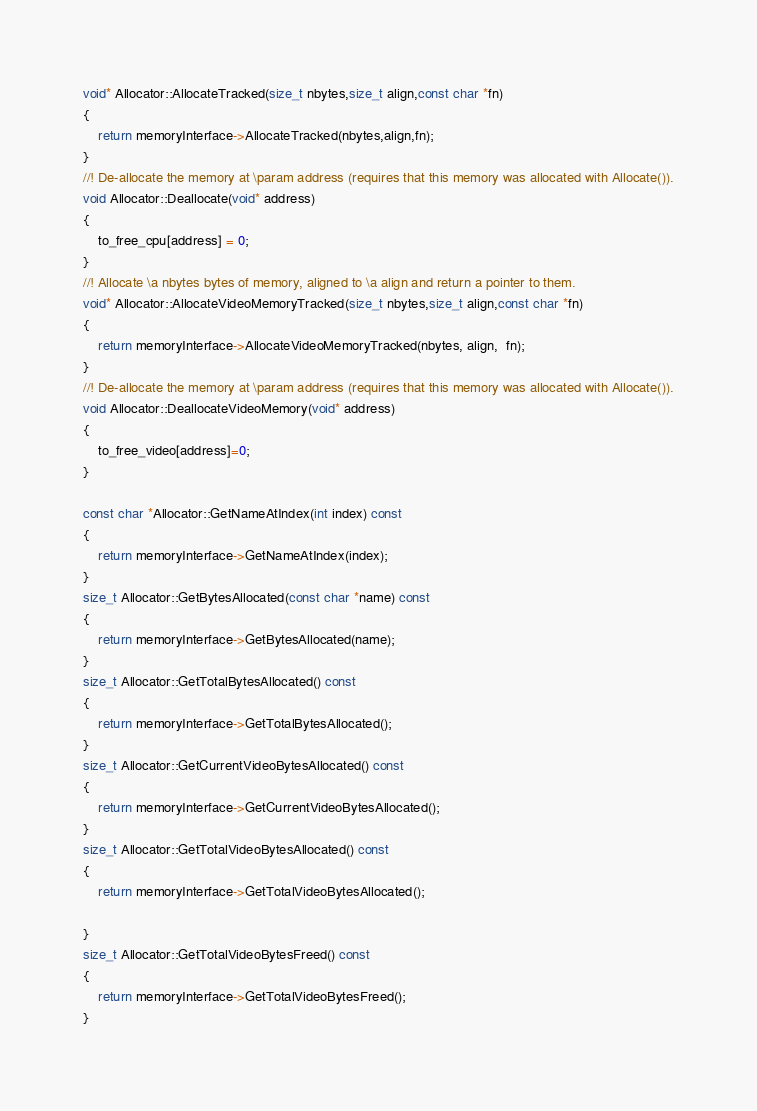<code> <loc_0><loc_0><loc_500><loc_500><_C++_>void* Allocator::AllocateTracked(size_t nbytes,size_t align,const char *fn)
{
	return memoryInterface->AllocateTracked(nbytes,align,fn);
}
//! De-allocate the memory at \param address (requires that this memory was allocated with Allocate()).
void Allocator::Deallocate(void* address)
{
	to_free_cpu[address] = 0;
}
//! Allocate \a nbytes bytes of memory, aligned to \a align and return a pointer to them.
void* Allocator::AllocateVideoMemoryTracked(size_t nbytes,size_t align,const char *fn)
{
	return memoryInterface->AllocateVideoMemoryTracked(nbytes, align,  fn);
}
//! De-allocate the memory at \param address (requires that this memory was allocated with Allocate()).
void Allocator::DeallocateVideoMemory(void* address)
{
	to_free_video[address]=0;
}

const char *Allocator::GetNameAtIndex(int index) const
{
	return memoryInterface->GetNameAtIndex(index);
}
size_t Allocator::GetBytesAllocated(const char *name) const
{
	return memoryInterface->GetBytesAllocated(name);
}
size_t Allocator::GetTotalBytesAllocated() const
{
	return memoryInterface->GetTotalBytesAllocated();
}
size_t Allocator::GetCurrentVideoBytesAllocated() const
{
	return memoryInterface->GetCurrentVideoBytesAllocated();
}
size_t Allocator::GetTotalVideoBytesAllocated() const
{
	return memoryInterface->GetTotalVideoBytesAllocated();

}
size_t Allocator::GetTotalVideoBytesFreed() const
{
	return memoryInterface->GetTotalVideoBytesFreed();
}</code> 